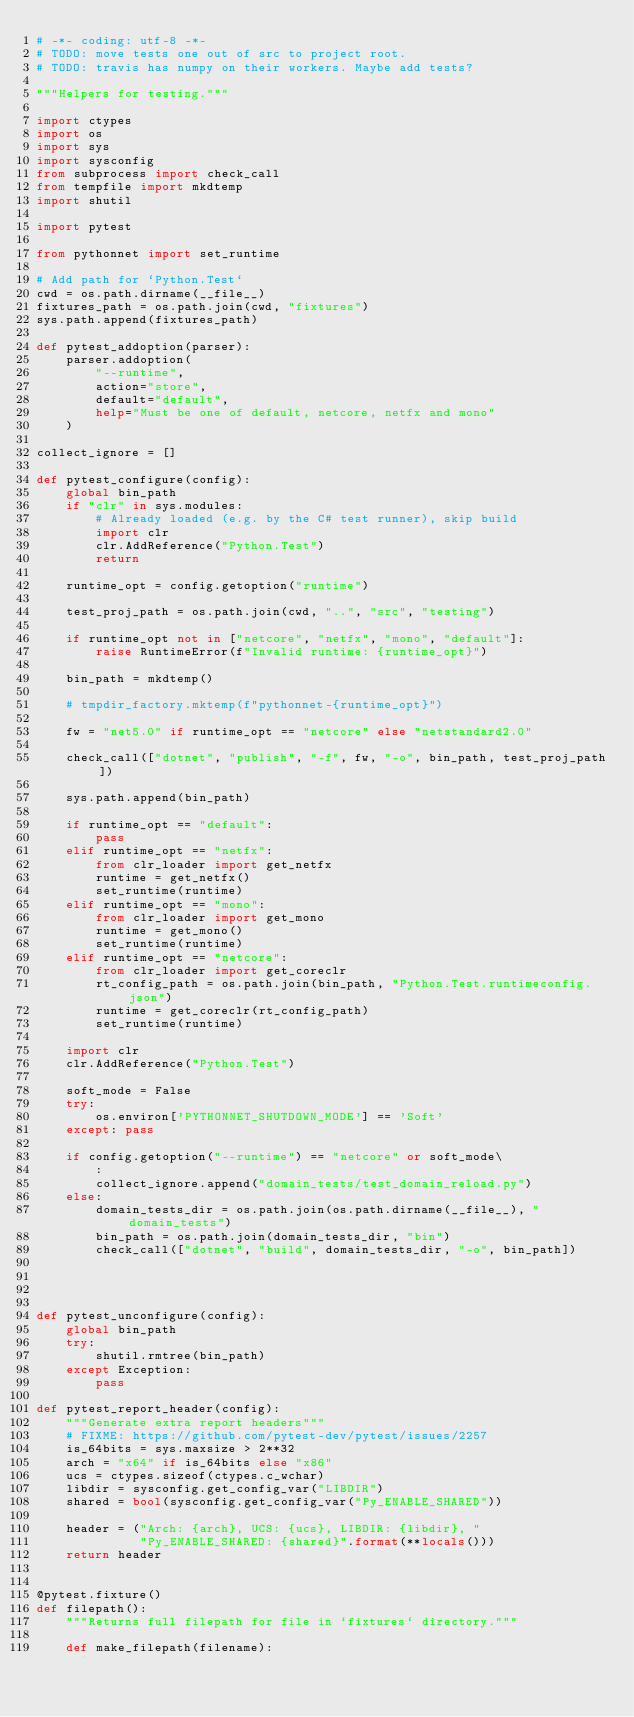<code> <loc_0><loc_0><loc_500><loc_500><_Python_># -*- coding: utf-8 -*-
# TODO: move tests one out of src to project root.
# TODO: travis has numpy on their workers. Maybe add tests?

"""Helpers for testing."""

import ctypes
import os
import sys
import sysconfig
from subprocess import check_call
from tempfile import mkdtemp
import shutil

import pytest

from pythonnet import set_runtime

# Add path for `Python.Test`
cwd = os.path.dirname(__file__)
fixtures_path = os.path.join(cwd, "fixtures")
sys.path.append(fixtures_path)

def pytest_addoption(parser):
    parser.addoption(
        "--runtime",
        action="store",
        default="default",
        help="Must be one of default, netcore, netfx and mono"
    )

collect_ignore = []

def pytest_configure(config):
    global bin_path
    if "clr" in sys.modules:
        # Already loaded (e.g. by the C# test runner), skip build
        import clr
        clr.AddReference("Python.Test")
        return

    runtime_opt = config.getoption("runtime")

    test_proj_path = os.path.join(cwd, "..", "src", "testing")

    if runtime_opt not in ["netcore", "netfx", "mono", "default"]:
        raise RuntimeError(f"Invalid runtime: {runtime_opt}")

    bin_path = mkdtemp()

    # tmpdir_factory.mktemp(f"pythonnet-{runtime_opt}")

    fw = "net5.0" if runtime_opt == "netcore" else "netstandard2.0"

    check_call(["dotnet", "publish", "-f", fw, "-o", bin_path, test_proj_path])

    sys.path.append(bin_path)

    if runtime_opt == "default":
        pass
    elif runtime_opt == "netfx":
        from clr_loader import get_netfx
        runtime = get_netfx()
        set_runtime(runtime)
    elif runtime_opt == "mono":
        from clr_loader import get_mono
        runtime = get_mono()
        set_runtime(runtime)
    elif runtime_opt == "netcore":
        from clr_loader import get_coreclr
        rt_config_path = os.path.join(bin_path, "Python.Test.runtimeconfig.json")
        runtime = get_coreclr(rt_config_path)
        set_runtime(runtime)

    import clr
    clr.AddReference("Python.Test")

    soft_mode = False
    try:
        os.environ['PYTHONNET_SHUTDOWN_MODE'] == 'Soft'
    except: pass

    if config.getoption("--runtime") == "netcore" or soft_mode\
        :
        collect_ignore.append("domain_tests/test_domain_reload.py")
    else:
        domain_tests_dir = os.path.join(os.path.dirname(__file__), "domain_tests")
        bin_path = os.path.join(domain_tests_dir, "bin")
        check_call(["dotnet", "build", domain_tests_dir, "-o", bin_path])




def pytest_unconfigure(config):
    global bin_path
    try:
        shutil.rmtree(bin_path)
    except Exception:
        pass

def pytest_report_header(config):
    """Generate extra report headers"""
    # FIXME: https://github.com/pytest-dev/pytest/issues/2257
    is_64bits = sys.maxsize > 2**32
    arch = "x64" if is_64bits else "x86"
    ucs = ctypes.sizeof(ctypes.c_wchar)
    libdir = sysconfig.get_config_var("LIBDIR")
    shared = bool(sysconfig.get_config_var("Py_ENABLE_SHARED"))

    header = ("Arch: {arch}, UCS: {ucs}, LIBDIR: {libdir}, "
              "Py_ENABLE_SHARED: {shared}".format(**locals()))
    return header


@pytest.fixture()
def filepath():
    """Returns full filepath for file in `fixtures` directory."""

    def make_filepath(filename):</code> 